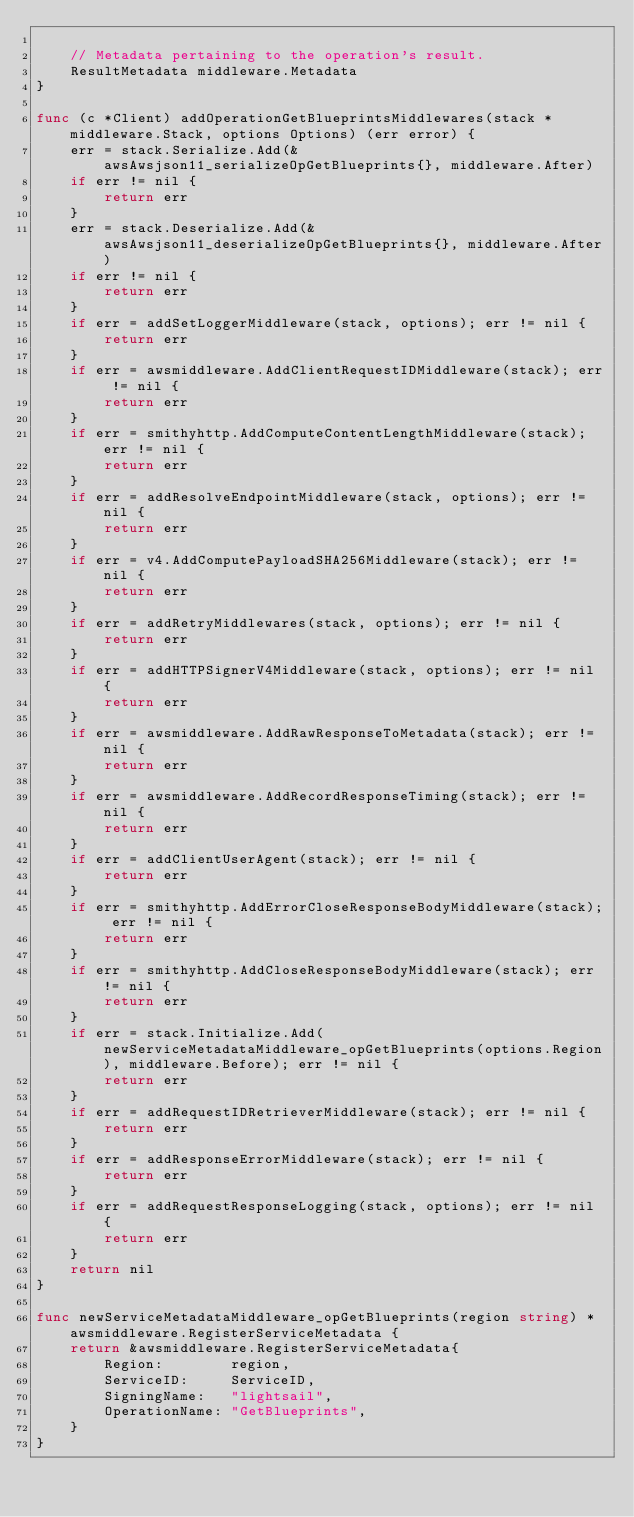Convert code to text. <code><loc_0><loc_0><loc_500><loc_500><_Go_>
	// Metadata pertaining to the operation's result.
	ResultMetadata middleware.Metadata
}

func (c *Client) addOperationGetBlueprintsMiddlewares(stack *middleware.Stack, options Options) (err error) {
	err = stack.Serialize.Add(&awsAwsjson11_serializeOpGetBlueprints{}, middleware.After)
	if err != nil {
		return err
	}
	err = stack.Deserialize.Add(&awsAwsjson11_deserializeOpGetBlueprints{}, middleware.After)
	if err != nil {
		return err
	}
	if err = addSetLoggerMiddleware(stack, options); err != nil {
		return err
	}
	if err = awsmiddleware.AddClientRequestIDMiddleware(stack); err != nil {
		return err
	}
	if err = smithyhttp.AddComputeContentLengthMiddleware(stack); err != nil {
		return err
	}
	if err = addResolveEndpointMiddleware(stack, options); err != nil {
		return err
	}
	if err = v4.AddComputePayloadSHA256Middleware(stack); err != nil {
		return err
	}
	if err = addRetryMiddlewares(stack, options); err != nil {
		return err
	}
	if err = addHTTPSignerV4Middleware(stack, options); err != nil {
		return err
	}
	if err = awsmiddleware.AddRawResponseToMetadata(stack); err != nil {
		return err
	}
	if err = awsmiddleware.AddRecordResponseTiming(stack); err != nil {
		return err
	}
	if err = addClientUserAgent(stack); err != nil {
		return err
	}
	if err = smithyhttp.AddErrorCloseResponseBodyMiddleware(stack); err != nil {
		return err
	}
	if err = smithyhttp.AddCloseResponseBodyMiddleware(stack); err != nil {
		return err
	}
	if err = stack.Initialize.Add(newServiceMetadataMiddleware_opGetBlueprints(options.Region), middleware.Before); err != nil {
		return err
	}
	if err = addRequestIDRetrieverMiddleware(stack); err != nil {
		return err
	}
	if err = addResponseErrorMiddleware(stack); err != nil {
		return err
	}
	if err = addRequestResponseLogging(stack, options); err != nil {
		return err
	}
	return nil
}

func newServiceMetadataMiddleware_opGetBlueprints(region string) *awsmiddleware.RegisterServiceMetadata {
	return &awsmiddleware.RegisterServiceMetadata{
		Region:        region,
		ServiceID:     ServiceID,
		SigningName:   "lightsail",
		OperationName: "GetBlueprints",
	}
}
</code> 